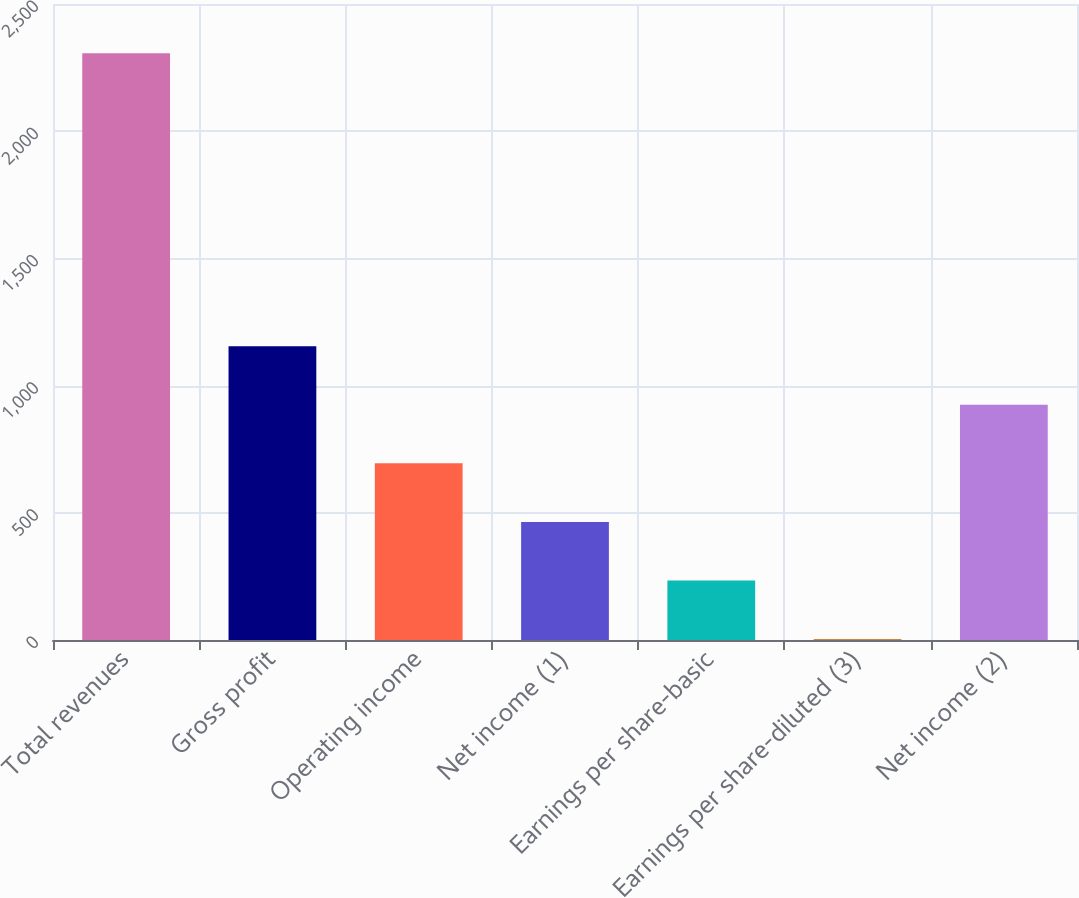Convert chart. <chart><loc_0><loc_0><loc_500><loc_500><bar_chart><fcel>Total revenues<fcel>Gross profit<fcel>Operating income<fcel>Net income (1)<fcel>Earnings per share-basic<fcel>Earnings per share-diluted (3)<fcel>Net income (2)<nl><fcel>2306<fcel>1154.9<fcel>694.46<fcel>464.24<fcel>234.02<fcel>3.8<fcel>924.68<nl></chart> 